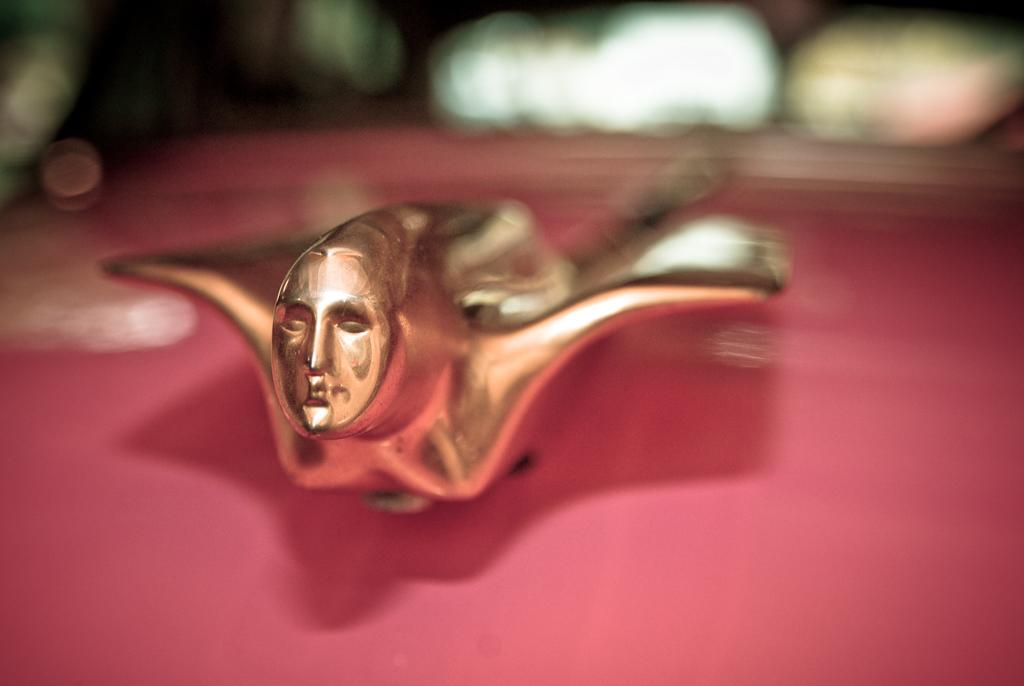What is the main subject of the image? The main subject of the image is a copper item of a person. What is the copper item placed on? The copper item is on a red color object. Can you describe the background of the image? The background of the image is blurred. What type of underwear is the person wearing in the image? There is no person wearing underwear in the image, as the main subject is a copper item of a person. 